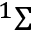Convert formula to latex. <formula><loc_0><loc_0><loc_500><loc_500>^ { 1 } \Sigma</formula> 